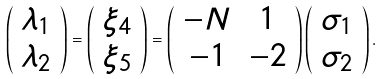Convert formula to latex. <formula><loc_0><loc_0><loc_500><loc_500>\left ( \begin{array} { c } \lambda _ { 1 } \\ \lambda _ { 2 } \end{array} \right ) = \left ( \begin{array} { c } \xi _ { 4 } \\ \xi _ { 5 } \end{array} \right ) = \left ( \begin{array} { c c } - N & 1 \\ - 1 & - 2 \end{array} \right ) \left ( \begin{array} { c } \sigma _ { 1 } \\ \sigma _ { 2 } \end{array} \right ) .</formula> 